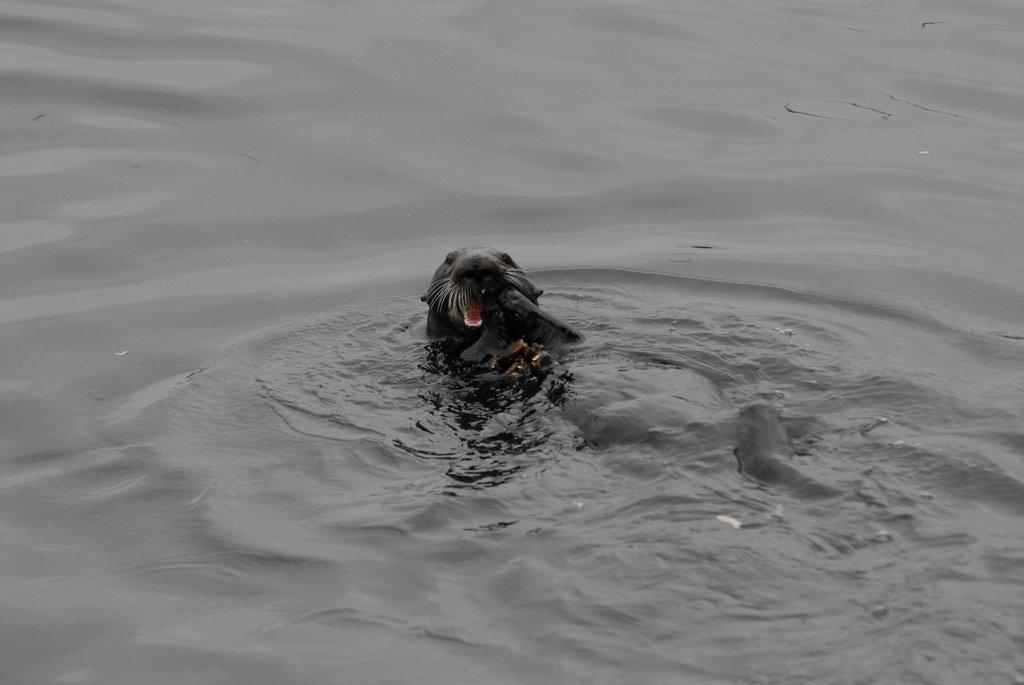What type of animal is present in the image? There is an aquatic animal in the image. Can you describe the environment in which the aquatic animal is situated? The aquatic animal is in the water. What type of earth is visible in the image? There is no earth visible in the image, as it features an aquatic animal in the water. What subject is the aquatic animal teaching in the image? The aquatic animal is not teaching any subject in the image, as animals do not engage in teaching activities. 